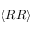Convert formula to latex. <formula><loc_0><loc_0><loc_500><loc_500>\langle R R \rangle</formula> 